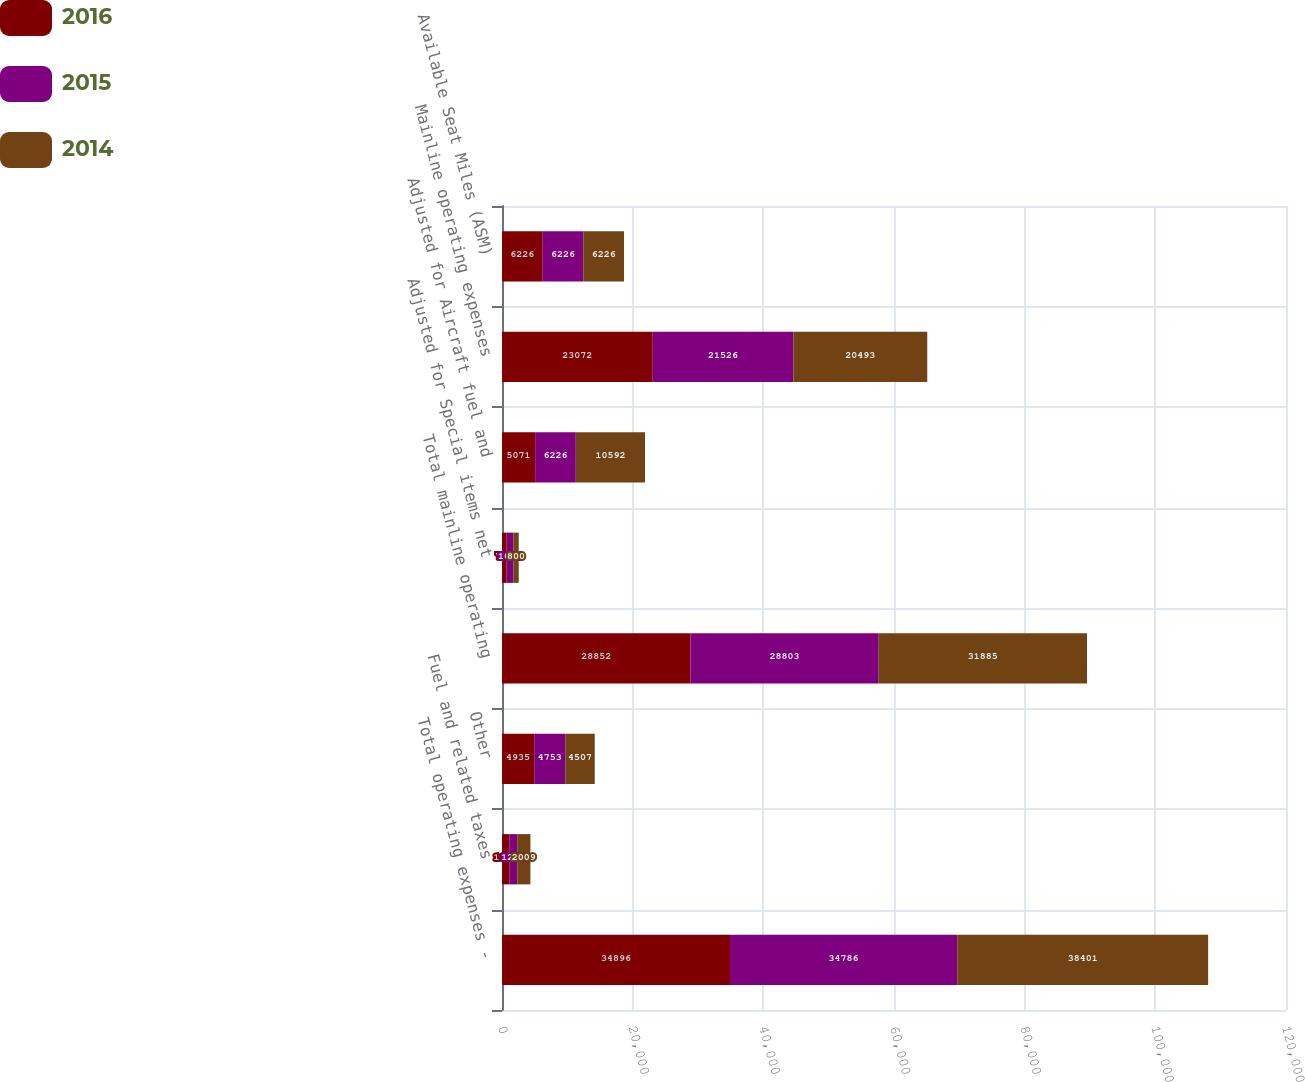<chart> <loc_0><loc_0><loc_500><loc_500><stacked_bar_chart><ecel><fcel>Total operating expenses -<fcel>Fuel and related taxes<fcel>Other<fcel>Total mainline operating<fcel>Adjusted for Special items net<fcel>Adjusted for Aircraft fuel and<fcel>Mainline operating expenses<fcel>Available Seat Miles (ASM)<nl><fcel>2016<fcel>34896<fcel>1109<fcel>4935<fcel>28852<fcel>709<fcel>5071<fcel>23072<fcel>6226<nl><fcel>2015<fcel>34786<fcel>1230<fcel>4753<fcel>28803<fcel>1051<fcel>6226<fcel>21526<fcel>6226<nl><fcel>2014<fcel>38401<fcel>2009<fcel>4507<fcel>31885<fcel>800<fcel>10592<fcel>20493<fcel>6226<nl></chart> 